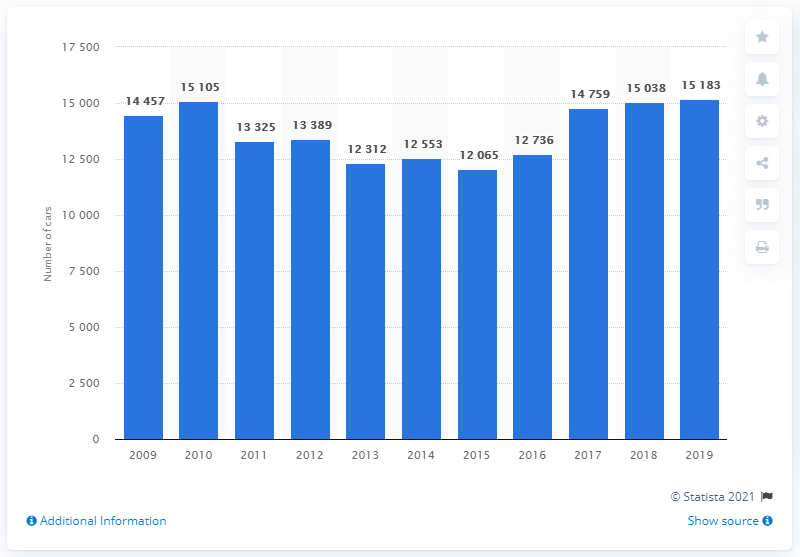List a handful of essential elements in this visual. In 2015, Toyota's sales increased. In 2019, a total of 15,183 Toyota vehicles were registered in Finland. 